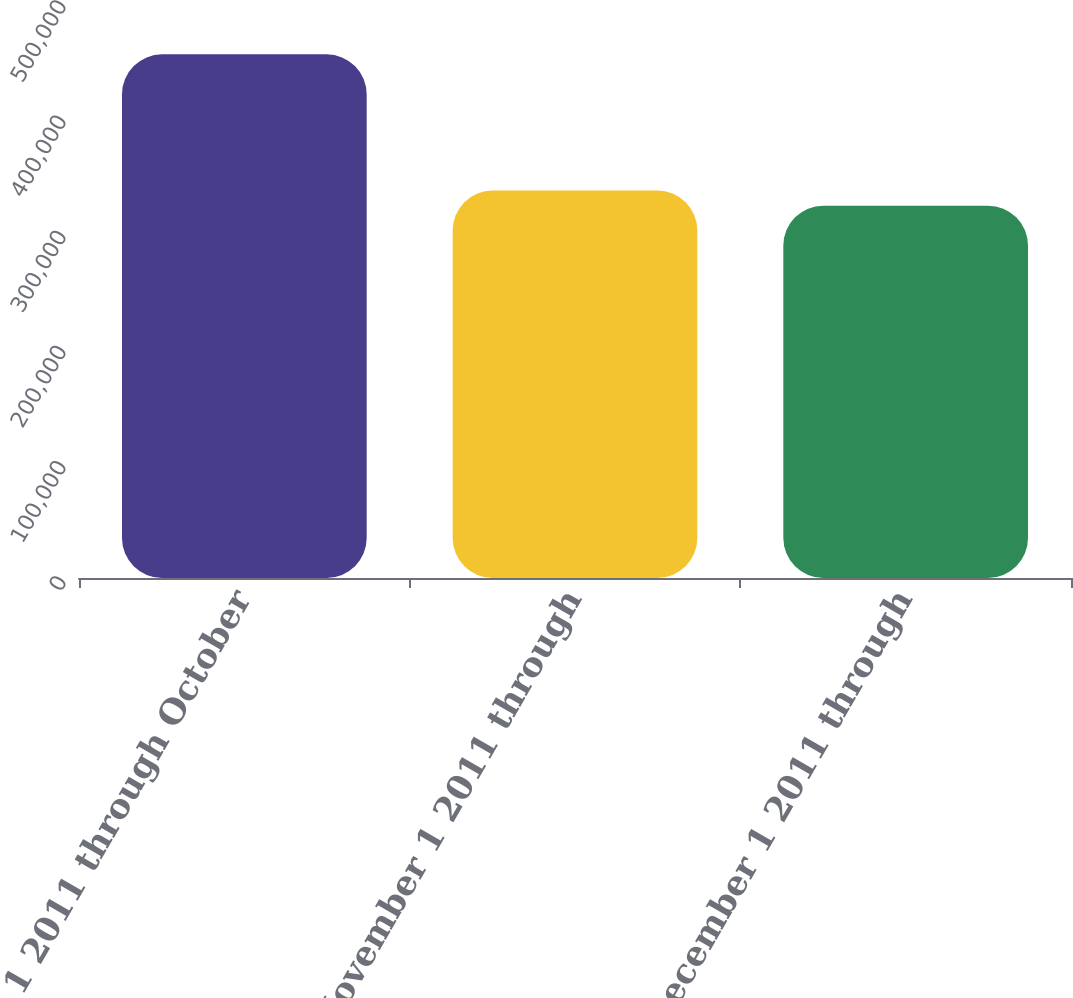Convert chart. <chart><loc_0><loc_0><loc_500><loc_500><bar_chart><fcel>October 1 2011 through October<fcel>November 1 2011 through<fcel>December 1 2011 through<nl><fcel>454557<fcel>336373<fcel>323241<nl></chart> 